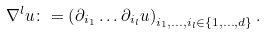Convert formula to latex. <formula><loc_0><loc_0><loc_500><loc_500>\nabla ^ { l } u \colon = \left ( \partial _ { i _ { 1 } } \dots \partial _ { i _ { l } } u \right ) _ { i _ { 1 } , \dots , i _ { l } \in \{ 1 , \dots , d \} } .</formula> 